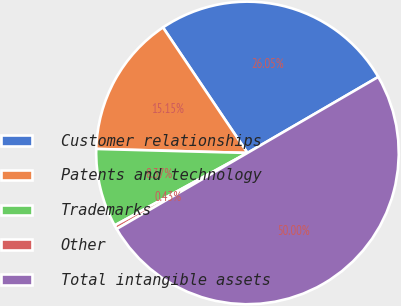Convert chart to OTSL. <chart><loc_0><loc_0><loc_500><loc_500><pie_chart><fcel>Customer relationships<fcel>Patents and technology<fcel>Trademarks<fcel>Other<fcel>Total intangible assets<nl><fcel>26.05%<fcel>15.15%<fcel>8.37%<fcel>0.43%<fcel>50.0%<nl></chart> 